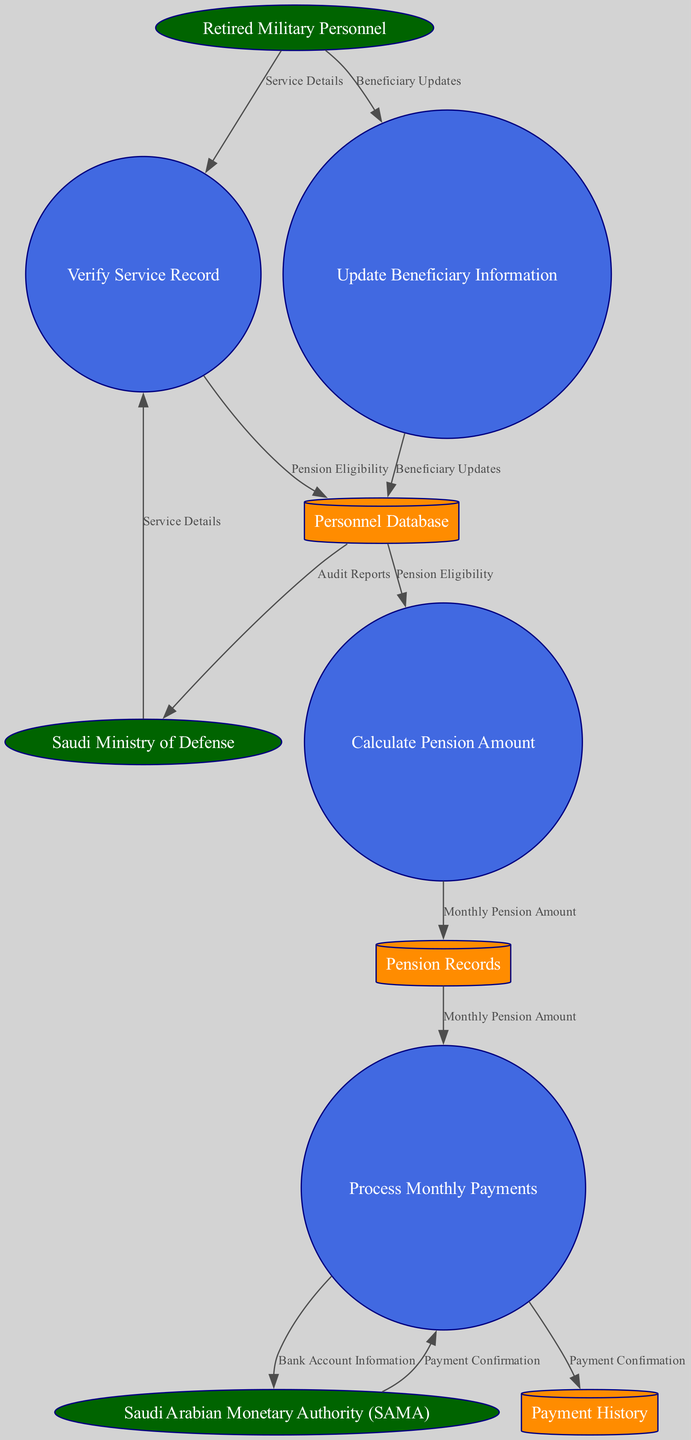How many external entities are present in the diagram? The diagram includes three external entities: Retired Military Personnel, Saudi Ministry of Defense, and Saudi Arabian Monetary Authority (SAMA).
Answer: 3 What is the first process listed in the diagram? The first process in the diagram is "Verify Service Record," reflecting the initial step in the pension disbursement workflow.
Answer: Verify Service Record Which data store receives the "Pension Eligibility" data flow? The data store that receives "Pension Eligibility" data flow from "Verify Service Record" is the "Personnel Database."
Answer: Personnel Database What entity is responsible for processing monthly payments? "Saudi Arabian Monetary Authority (SAMA)" is specifically responsible for processing the monthly payments as indicated by the data flow connections in the diagram.
Answer: Saudi Arabian Monetary Authority (SAMA) How many data flows are depicted in the diagram? There are eight distinct data flows outlined in the diagram that represent the interactions between entities, processes, and data stores.
Answer: 8 What does the "Update Beneficiary Information" process send to the "Personnel Database"? The "Update Beneficiary Information" process sends "Beneficiary Updates" to the "Personnel Database," indicating a direct flow of updated information.
Answer: Beneficiary Updates What type of node is "Payment History"? "Payment History" is classified as a data store in the diagram, which is represented as a cylinder shape, indicating it serves as a repository for collected data.
Answer: Data Store For which process is "Monthly Pension Amount" an output? "Monthly Pension Amount" is an output specifically of the "Calculate Pension Amount" process, indicating a direct result of the calculations performed there.
Answer: Calculate Pension Amount Which external entity provides "Payment Confirmation"? "Saudi Arabian Monetary Authority (SAMA)" is the external entity that provides "Payment Confirmation" back after processing monthly payments.
Answer: Saudi Arabian Monetary Authority (SAMA) 